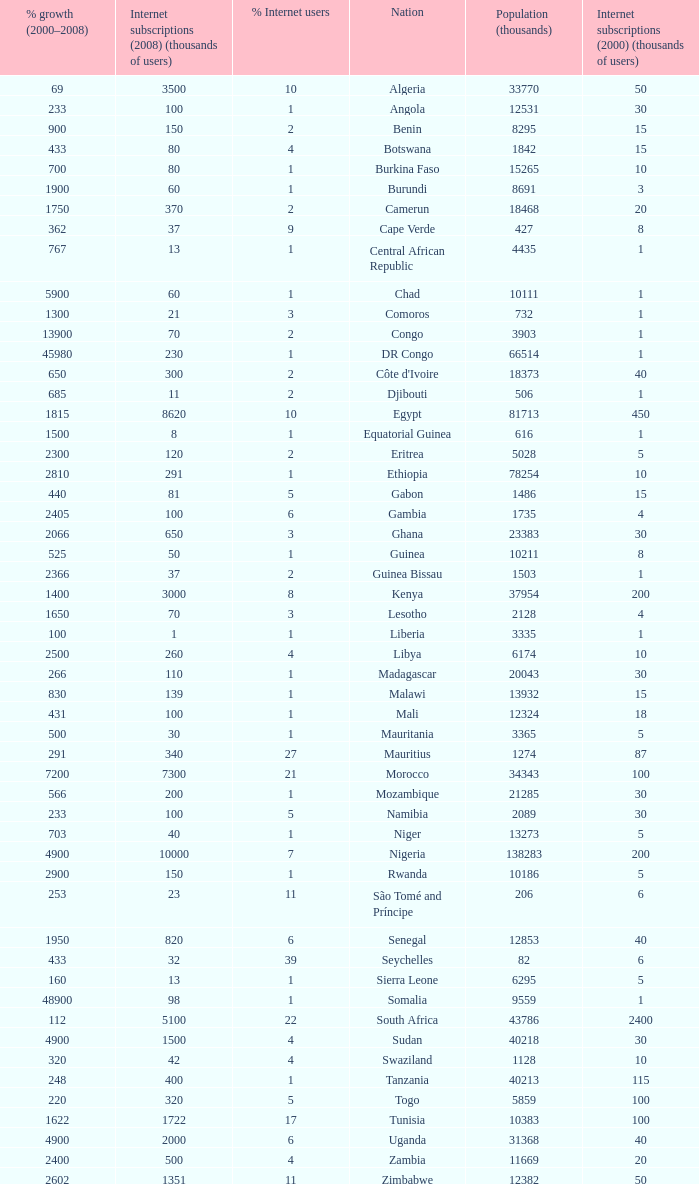What is the maximum percentage grown 2000-2008 in burundi 1900.0. 